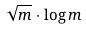<formula> <loc_0><loc_0><loc_500><loc_500>\sqrt { m } \cdot \log m</formula> 